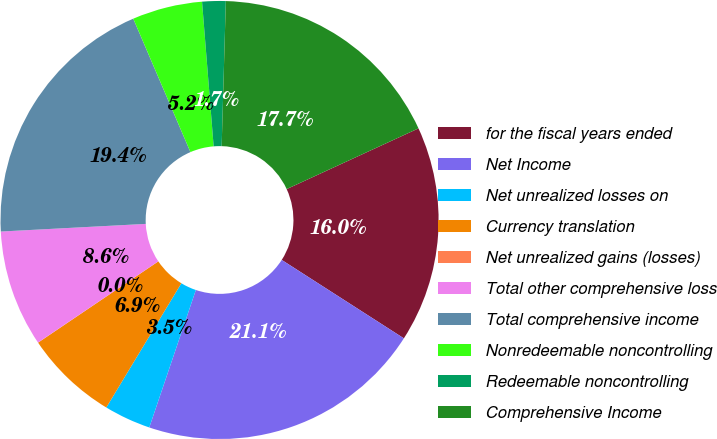<chart> <loc_0><loc_0><loc_500><loc_500><pie_chart><fcel>for the fiscal years ended<fcel>Net Income<fcel>Net unrealized losses on<fcel>Currency translation<fcel>Net unrealized gains (losses)<fcel>Total other comprehensive loss<fcel>Total comprehensive income<fcel>Nonredeemable noncontrolling<fcel>Redeemable noncontrolling<fcel>Comprehensive Income<nl><fcel>15.95%<fcel>21.11%<fcel>3.45%<fcel>6.89%<fcel>0.01%<fcel>8.61%<fcel>19.39%<fcel>5.17%<fcel>1.73%<fcel>17.67%<nl></chart> 